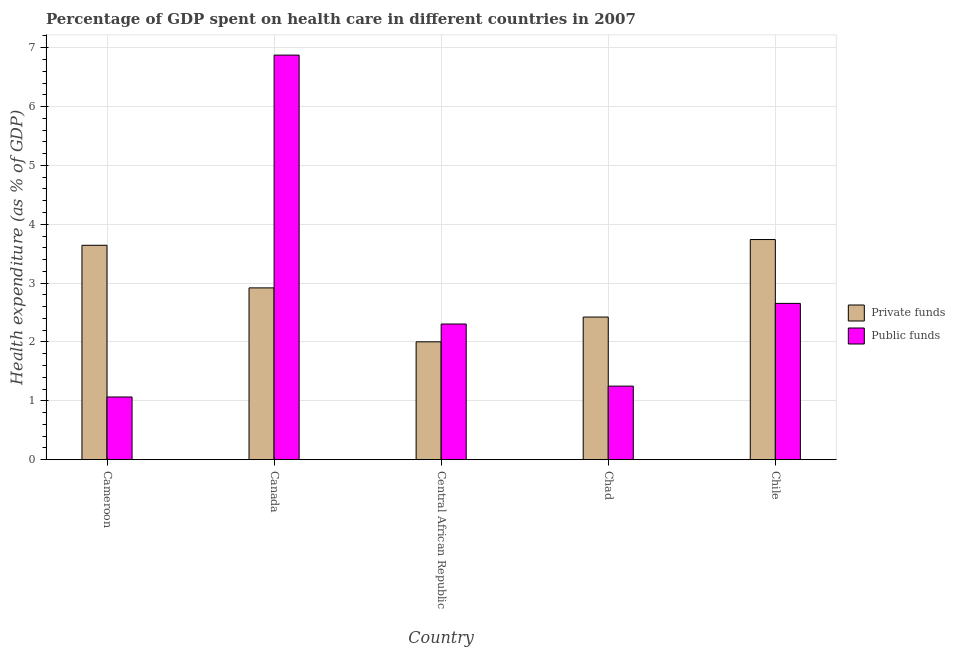How many bars are there on the 2nd tick from the left?
Your answer should be very brief. 2. How many bars are there on the 1st tick from the right?
Offer a terse response. 2. In how many cases, is the number of bars for a given country not equal to the number of legend labels?
Keep it short and to the point. 0. What is the amount of private funds spent in healthcare in Canada?
Your response must be concise. 2.92. Across all countries, what is the maximum amount of private funds spent in healthcare?
Your answer should be compact. 3.74. Across all countries, what is the minimum amount of public funds spent in healthcare?
Offer a terse response. 1.07. In which country was the amount of private funds spent in healthcare maximum?
Keep it short and to the point. Chile. In which country was the amount of private funds spent in healthcare minimum?
Offer a terse response. Central African Republic. What is the total amount of private funds spent in healthcare in the graph?
Your answer should be very brief. 14.73. What is the difference between the amount of public funds spent in healthcare in Cameroon and that in Chile?
Ensure brevity in your answer.  -1.59. What is the difference between the amount of private funds spent in healthcare in Central African Republic and the amount of public funds spent in healthcare in Cameroon?
Your answer should be very brief. 0.94. What is the average amount of private funds spent in healthcare per country?
Your answer should be compact. 2.95. What is the difference between the amount of public funds spent in healthcare and amount of private funds spent in healthcare in Central African Republic?
Your response must be concise. 0.3. What is the ratio of the amount of private funds spent in healthcare in Cameroon to that in Canada?
Make the answer very short. 1.25. Is the amount of public funds spent in healthcare in Cameroon less than that in Chile?
Make the answer very short. Yes. Is the difference between the amount of private funds spent in healthcare in Canada and Central African Republic greater than the difference between the amount of public funds spent in healthcare in Canada and Central African Republic?
Make the answer very short. No. What is the difference between the highest and the second highest amount of private funds spent in healthcare?
Keep it short and to the point. 0.1. What is the difference between the highest and the lowest amount of public funds spent in healthcare?
Offer a very short reply. 5.81. In how many countries, is the amount of public funds spent in healthcare greater than the average amount of public funds spent in healthcare taken over all countries?
Your answer should be very brief. 1. Is the sum of the amount of public funds spent in healthcare in Canada and Central African Republic greater than the maximum amount of private funds spent in healthcare across all countries?
Your answer should be compact. Yes. What does the 1st bar from the left in Cameroon represents?
Your response must be concise. Private funds. What does the 1st bar from the right in Chile represents?
Keep it short and to the point. Public funds. Are all the bars in the graph horizontal?
Ensure brevity in your answer.  No. What is the difference between two consecutive major ticks on the Y-axis?
Keep it short and to the point. 1. Does the graph contain grids?
Give a very brief answer. Yes. Where does the legend appear in the graph?
Keep it short and to the point. Center right. How many legend labels are there?
Offer a very short reply. 2. How are the legend labels stacked?
Your response must be concise. Vertical. What is the title of the graph?
Keep it short and to the point. Percentage of GDP spent on health care in different countries in 2007. What is the label or title of the Y-axis?
Keep it short and to the point. Health expenditure (as % of GDP). What is the Health expenditure (as % of GDP) of Private funds in Cameroon?
Your answer should be compact. 3.64. What is the Health expenditure (as % of GDP) in Public funds in Cameroon?
Keep it short and to the point. 1.07. What is the Health expenditure (as % of GDP) in Private funds in Canada?
Provide a short and direct response. 2.92. What is the Health expenditure (as % of GDP) in Public funds in Canada?
Give a very brief answer. 6.87. What is the Health expenditure (as % of GDP) in Private funds in Central African Republic?
Your answer should be compact. 2. What is the Health expenditure (as % of GDP) of Public funds in Central African Republic?
Keep it short and to the point. 2.31. What is the Health expenditure (as % of GDP) in Private funds in Chad?
Your answer should be very brief. 2.42. What is the Health expenditure (as % of GDP) in Public funds in Chad?
Give a very brief answer. 1.25. What is the Health expenditure (as % of GDP) of Private funds in Chile?
Your answer should be very brief. 3.74. What is the Health expenditure (as % of GDP) in Public funds in Chile?
Ensure brevity in your answer.  2.66. Across all countries, what is the maximum Health expenditure (as % of GDP) of Private funds?
Offer a very short reply. 3.74. Across all countries, what is the maximum Health expenditure (as % of GDP) of Public funds?
Offer a terse response. 6.87. Across all countries, what is the minimum Health expenditure (as % of GDP) in Private funds?
Make the answer very short. 2. Across all countries, what is the minimum Health expenditure (as % of GDP) in Public funds?
Make the answer very short. 1.07. What is the total Health expenditure (as % of GDP) of Private funds in the graph?
Ensure brevity in your answer.  14.73. What is the total Health expenditure (as % of GDP) of Public funds in the graph?
Your answer should be compact. 14.15. What is the difference between the Health expenditure (as % of GDP) in Private funds in Cameroon and that in Canada?
Your answer should be compact. 0.72. What is the difference between the Health expenditure (as % of GDP) in Public funds in Cameroon and that in Canada?
Your response must be concise. -5.81. What is the difference between the Health expenditure (as % of GDP) of Private funds in Cameroon and that in Central African Republic?
Make the answer very short. 1.64. What is the difference between the Health expenditure (as % of GDP) of Public funds in Cameroon and that in Central African Republic?
Your response must be concise. -1.24. What is the difference between the Health expenditure (as % of GDP) of Private funds in Cameroon and that in Chad?
Your answer should be compact. 1.22. What is the difference between the Health expenditure (as % of GDP) in Public funds in Cameroon and that in Chad?
Provide a short and direct response. -0.18. What is the difference between the Health expenditure (as % of GDP) in Private funds in Cameroon and that in Chile?
Your answer should be compact. -0.1. What is the difference between the Health expenditure (as % of GDP) of Public funds in Cameroon and that in Chile?
Offer a terse response. -1.59. What is the difference between the Health expenditure (as % of GDP) in Private funds in Canada and that in Central African Republic?
Keep it short and to the point. 0.92. What is the difference between the Health expenditure (as % of GDP) in Public funds in Canada and that in Central African Republic?
Offer a terse response. 4.57. What is the difference between the Health expenditure (as % of GDP) in Private funds in Canada and that in Chad?
Make the answer very short. 0.5. What is the difference between the Health expenditure (as % of GDP) in Public funds in Canada and that in Chad?
Give a very brief answer. 5.62. What is the difference between the Health expenditure (as % of GDP) of Private funds in Canada and that in Chile?
Offer a terse response. -0.82. What is the difference between the Health expenditure (as % of GDP) in Public funds in Canada and that in Chile?
Your response must be concise. 4.22. What is the difference between the Health expenditure (as % of GDP) of Private funds in Central African Republic and that in Chad?
Give a very brief answer. -0.42. What is the difference between the Health expenditure (as % of GDP) of Public funds in Central African Republic and that in Chad?
Your answer should be very brief. 1.06. What is the difference between the Health expenditure (as % of GDP) of Private funds in Central African Republic and that in Chile?
Offer a terse response. -1.74. What is the difference between the Health expenditure (as % of GDP) of Public funds in Central African Republic and that in Chile?
Keep it short and to the point. -0.35. What is the difference between the Health expenditure (as % of GDP) of Private funds in Chad and that in Chile?
Your answer should be very brief. -1.32. What is the difference between the Health expenditure (as % of GDP) of Public funds in Chad and that in Chile?
Your answer should be compact. -1.41. What is the difference between the Health expenditure (as % of GDP) of Private funds in Cameroon and the Health expenditure (as % of GDP) of Public funds in Canada?
Make the answer very short. -3.23. What is the difference between the Health expenditure (as % of GDP) in Private funds in Cameroon and the Health expenditure (as % of GDP) in Public funds in Central African Republic?
Keep it short and to the point. 1.34. What is the difference between the Health expenditure (as % of GDP) of Private funds in Cameroon and the Health expenditure (as % of GDP) of Public funds in Chad?
Your answer should be compact. 2.39. What is the difference between the Health expenditure (as % of GDP) in Private funds in Cameroon and the Health expenditure (as % of GDP) in Public funds in Chile?
Provide a short and direct response. 0.99. What is the difference between the Health expenditure (as % of GDP) of Private funds in Canada and the Health expenditure (as % of GDP) of Public funds in Central African Republic?
Your answer should be very brief. 0.61. What is the difference between the Health expenditure (as % of GDP) in Private funds in Canada and the Health expenditure (as % of GDP) in Public funds in Chad?
Make the answer very short. 1.67. What is the difference between the Health expenditure (as % of GDP) of Private funds in Canada and the Health expenditure (as % of GDP) of Public funds in Chile?
Your answer should be very brief. 0.26. What is the difference between the Health expenditure (as % of GDP) of Private funds in Central African Republic and the Health expenditure (as % of GDP) of Public funds in Chad?
Your response must be concise. 0.75. What is the difference between the Health expenditure (as % of GDP) of Private funds in Central African Republic and the Health expenditure (as % of GDP) of Public funds in Chile?
Your response must be concise. -0.65. What is the difference between the Health expenditure (as % of GDP) in Private funds in Chad and the Health expenditure (as % of GDP) in Public funds in Chile?
Give a very brief answer. -0.23. What is the average Health expenditure (as % of GDP) of Private funds per country?
Provide a succinct answer. 2.95. What is the average Health expenditure (as % of GDP) in Public funds per country?
Your answer should be compact. 2.83. What is the difference between the Health expenditure (as % of GDP) of Private funds and Health expenditure (as % of GDP) of Public funds in Cameroon?
Give a very brief answer. 2.58. What is the difference between the Health expenditure (as % of GDP) in Private funds and Health expenditure (as % of GDP) in Public funds in Canada?
Provide a succinct answer. -3.96. What is the difference between the Health expenditure (as % of GDP) in Private funds and Health expenditure (as % of GDP) in Public funds in Central African Republic?
Make the answer very short. -0.3. What is the difference between the Health expenditure (as % of GDP) of Private funds and Health expenditure (as % of GDP) of Public funds in Chad?
Ensure brevity in your answer.  1.17. What is the difference between the Health expenditure (as % of GDP) in Private funds and Health expenditure (as % of GDP) in Public funds in Chile?
Make the answer very short. 1.09. What is the ratio of the Health expenditure (as % of GDP) in Private funds in Cameroon to that in Canada?
Make the answer very short. 1.25. What is the ratio of the Health expenditure (as % of GDP) in Public funds in Cameroon to that in Canada?
Offer a very short reply. 0.15. What is the ratio of the Health expenditure (as % of GDP) of Private funds in Cameroon to that in Central African Republic?
Give a very brief answer. 1.82. What is the ratio of the Health expenditure (as % of GDP) of Public funds in Cameroon to that in Central African Republic?
Your answer should be compact. 0.46. What is the ratio of the Health expenditure (as % of GDP) of Private funds in Cameroon to that in Chad?
Keep it short and to the point. 1.5. What is the ratio of the Health expenditure (as % of GDP) of Public funds in Cameroon to that in Chad?
Your response must be concise. 0.85. What is the ratio of the Health expenditure (as % of GDP) in Private funds in Cameroon to that in Chile?
Keep it short and to the point. 0.97. What is the ratio of the Health expenditure (as % of GDP) of Public funds in Cameroon to that in Chile?
Your answer should be very brief. 0.4. What is the ratio of the Health expenditure (as % of GDP) of Private funds in Canada to that in Central African Republic?
Give a very brief answer. 1.46. What is the ratio of the Health expenditure (as % of GDP) of Public funds in Canada to that in Central African Republic?
Keep it short and to the point. 2.98. What is the ratio of the Health expenditure (as % of GDP) of Private funds in Canada to that in Chad?
Offer a terse response. 1.2. What is the ratio of the Health expenditure (as % of GDP) in Public funds in Canada to that in Chad?
Offer a very short reply. 5.5. What is the ratio of the Health expenditure (as % of GDP) in Private funds in Canada to that in Chile?
Offer a very short reply. 0.78. What is the ratio of the Health expenditure (as % of GDP) in Public funds in Canada to that in Chile?
Offer a terse response. 2.59. What is the ratio of the Health expenditure (as % of GDP) of Private funds in Central African Republic to that in Chad?
Ensure brevity in your answer.  0.83. What is the ratio of the Health expenditure (as % of GDP) in Public funds in Central African Republic to that in Chad?
Provide a short and direct response. 1.84. What is the ratio of the Health expenditure (as % of GDP) of Private funds in Central African Republic to that in Chile?
Keep it short and to the point. 0.54. What is the ratio of the Health expenditure (as % of GDP) in Public funds in Central African Republic to that in Chile?
Provide a short and direct response. 0.87. What is the ratio of the Health expenditure (as % of GDP) in Private funds in Chad to that in Chile?
Your answer should be compact. 0.65. What is the ratio of the Health expenditure (as % of GDP) of Public funds in Chad to that in Chile?
Your answer should be compact. 0.47. What is the difference between the highest and the second highest Health expenditure (as % of GDP) of Private funds?
Ensure brevity in your answer.  0.1. What is the difference between the highest and the second highest Health expenditure (as % of GDP) of Public funds?
Provide a short and direct response. 4.22. What is the difference between the highest and the lowest Health expenditure (as % of GDP) of Private funds?
Your answer should be very brief. 1.74. What is the difference between the highest and the lowest Health expenditure (as % of GDP) in Public funds?
Provide a short and direct response. 5.81. 